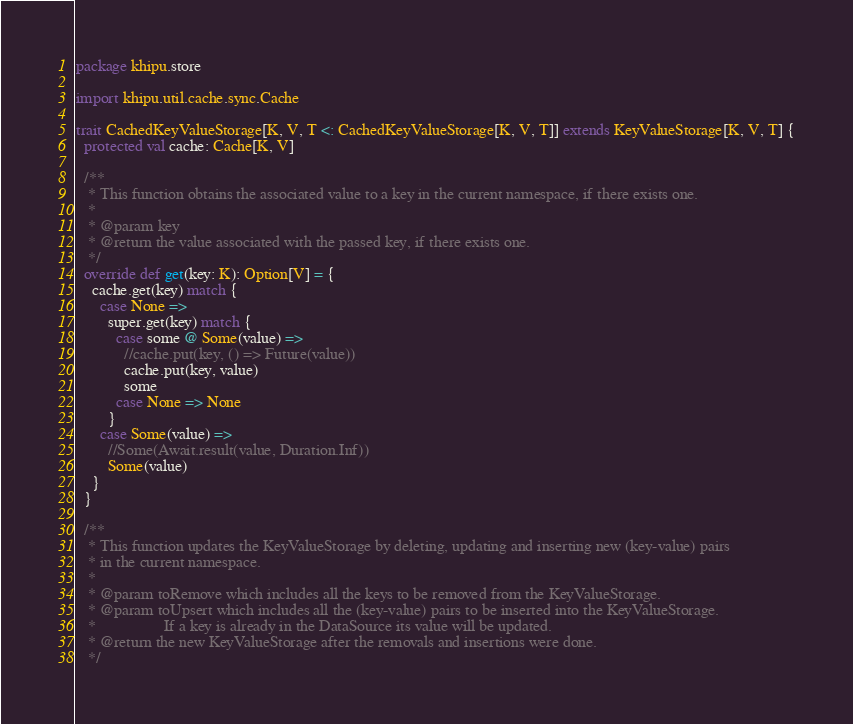Convert code to text. <code><loc_0><loc_0><loc_500><loc_500><_Scala_>package khipu.store

import khipu.util.cache.sync.Cache

trait CachedKeyValueStorage[K, V, T <: CachedKeyValueStorage[K, V, T]] extends KeyValueStorage[K, V, T] {
  protected val cache: Cache[K, V]

  /**
   * This function obtains the associated value to a key in the current namespace, if there exists one.
   *
   * @param key
   * @return the value associated with the passed key, if there exists one.
   */
  override def get(key: K): Option[V] = {
    cache.get(key) match {
      case None =>
        super.get(key) match {
          case some @ Some(value) =>
            //cache.put(key, () => Future(value))
            cache.put(key, value)
            some
          case None => None
        }
      case Some(value) =>
        //Some(Await.result(value, Duration.Inf))
        Some(value)
    }
  }

  /**
   * This function updates the KeyValueStorage by deleting, updating and inserting new (key-value) pairs
   * in the current namespace.
   *
   * @param toRemove which includes all the keys to be removed from the KeyValueStorage.
   * @param toUpsert which includes all the (key-value) pairs to be inserted into the KeyValueStorage.
   *                 If a key is already in the DataSource its value will be updated.
   * @return the new KeyValueStorage after the removals and insertions were done.
   */</code> 